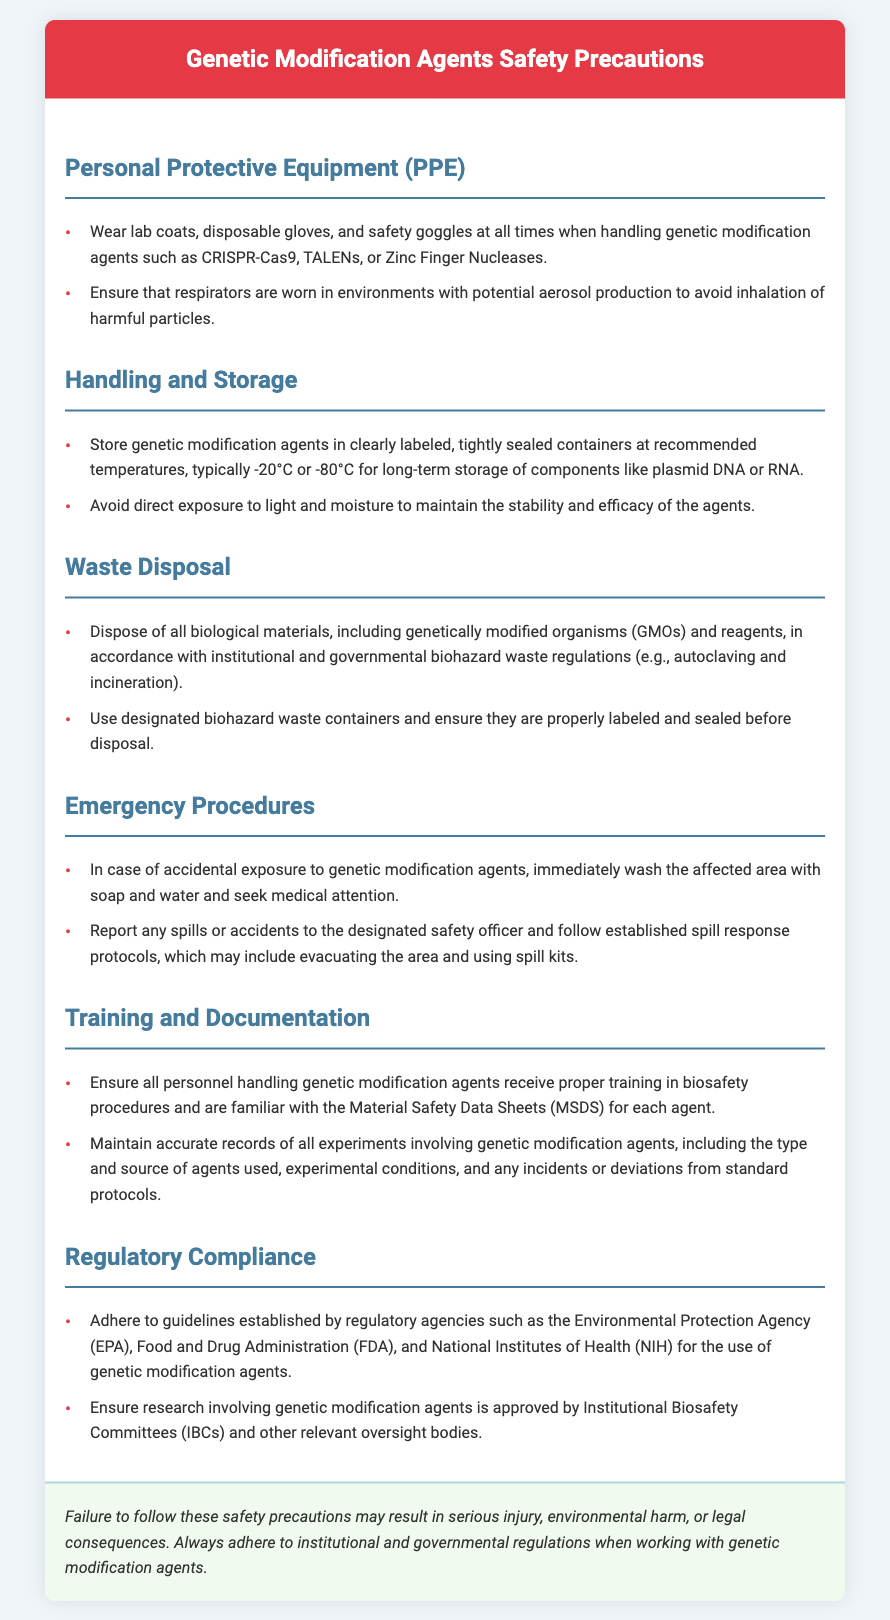What should be worn at all times when handling genetic modification agents? The document specifies that lab coats, disposable gloves, and safety goggles should be worn at all times when handling genetic modification agents.
Answer: Lab coats, disposable gloves, and safety goggles What temperature is recommended for long-term storage of genetic modification agents? The document advises storing genetic modification agents at recommended temperatures, typically -20°C or -80°C for long-term storage.
Answer: -20°C or -80°C What should be done in case of accidental exposure to genetic modification agents? In the event of accidental exposure, the document states that the affected area should be washed with soap and water and medical attention sought.
Answer: Wash with soap and water and seek medical attention Which regulatory agency guidelines should be adhered to regarding genetic modification agents? The document mentions that guidelines established by regulatory agencies like the Environmental Protection Agency (EPA) and Food and Drug Administration (FDA) should be followed.
Answer: Environmental Protection Agency (EPA) and Food and Drug Administration (FDA) What type of waste container should be used for disposal of biological materials? The document indicates that designated biohazard waste containers should be used for the disposal of biological materials.
Answer: Designated biohazard waste containers What is required for personnel handling genetic modification agents according to training and documentation? The document states that all personnel handling genetic modification agents must receive proper training in biosafety procedures and be familiar with the Material Safety Data Sheets (MSDS).
Answer: Proper training in biosafety procedures and familiarity with MSDS What should be done with incidents or deviations from standard protocols? The document specifies that accurate records of all experiments, including any incidents or deviations from standard protocols, must be maintained.
Answer: Maintain accurate records What is the consequence of failing to follow safety precautions? The document warns that failure to follow these safety precautions may result in serious injury, environmental harm, or legal consequences.
Answer: Serious injury, environmental harm, or legal consequences 